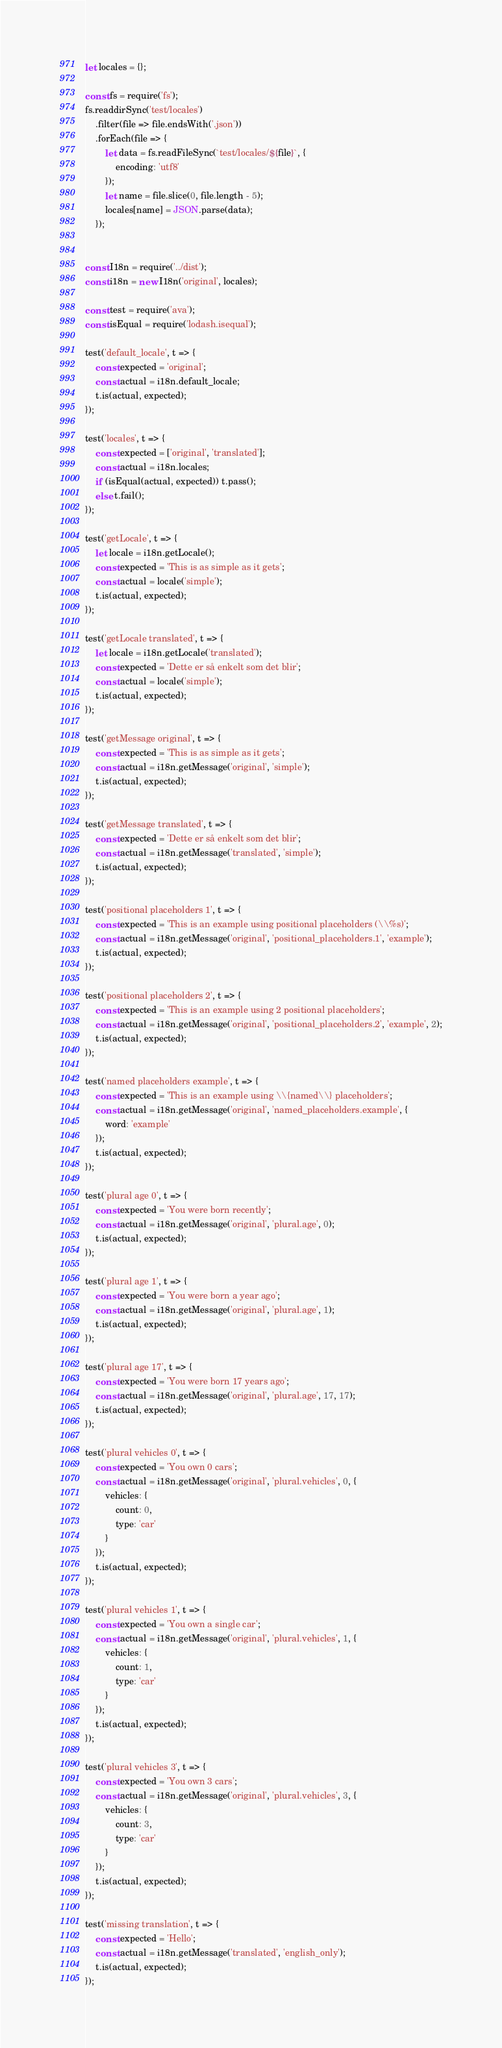Convert code to text. <code><loc_0><loc_0><loc_500><loc_500><_JavaScript_>let locales = {};

const fs = require('fs');
fs.readdirSync('test/locales')
	.filter(file => file.endsWith('.json'))
	.forEach(file => {
		let data = fs.readFileSync(`test/locales/${file}`, {
			encoding: 'utf8'
		});
		let name = file.slice(0, file.length - 5);
		locales[name] = JSON.parse(data);
	});


const I18n = require('../dist');
const i18n = new I18n('original', locales);

const test = require('ava');
const isEqual = require('lodash.isequal');

test('default_locale', t => {
	const expected = 'original';
	const actual = i18n.default_locale;
	t.is(actual, expected);
});

test('locales', t => {
	const expected = ['original', 'translated'];
	const actual = i18n.locales;
	if (isEqual(actual, expected)) t.pass();
	else t.fail();
});

test('getLocale', t => {
	let locale = i18n.getLocale();
	const expected = 'This is as simple as it gets';
	const actual = locale('simple');
	t.is(actual, expected);
});

test('getLocale translated', t => {
	let locale = i18n.getLocale('translated');
	const expected = 'Dette er så enkelt som det blir';
	const actual = locale('simple');
	t.is(actual, expected);
});

test('getMessage original', t => {
	const expected = 'This is as simple as it gets';
	const actual = i18n.getMessage('original', 'simple');
	t.is(actual, expected);
});

test('getMessage translated', t => {
	const expected = 'Dette er så enkelt som det blir';
	const actual = i18n.getMessage('translated', 'simple');
	t.is(actual, expected);
});

test('positional placeholders 1', t => {
	const expected = 'This is an example using positional placeholders (\\%s)';
	const actual = i18n.getMessage('original', 'positional_placeholders.1', 'example');
	t.is(actual, expected);
});

test('positional placeholders 2', t => {
	const expected = 'This is an example using 2 positional placeholders';
	const actual = i18n.getMessage('original', 'positional_placeholders.2', 'example', 2);
	t.is(actual, expected);
});

test('named placeholders example', t => {
	const expected = 'This is an example using \\{named\\} placeholders';
	const actual = i18n.getMessage('original', 'named_placeholders.example', {
		word: 'example'
	});
	t.is(actual, expected);
});

test('plural age 0', t => {
	const expected = 'You were born recently';
	const actual = i18n.getMessage('original', 'plural.age', 0);
	t.is(actual, expected);
});

test('plural age 1', t => {
	const expected = 'You were born a year ago';
	const actual = i18n.getMessage('original', 'plural.age', 1);
	t.is(actual, expected);
});

test('plural age 17', t => {
	const expected = 'You were born 17 years ago';
	const actual = i18n.getMessage('original', 'plural.age', 17, 17);
	t.is(actual, expected);
});

test('plural vehicles 0', t => {
	const expected = 'You own 0 cars';
	const actual = i18n.getMessage('original', 'plural.vehicles', 0, {
		vehicles: {
			count: 0,
			type: 'car'
		}
	});
	t.is(actual, expected);
});

test('plural vehicles 1', t => {
	const expected = 'You own a single car';
	const actual = i18n.getMessage('original', 'plural.vehicles', 1, {
		vehicles: {
			count: 1,
			type: 'car'
		}
	});
	t.is(actual, expected);
});

test('plural vehicles 3', t => {
	const expected = 'You own 3 cars';
	const actual = i18n.getMessage('original', 'plural.vehicles', 3, {
		vehicles: {
			count: 3,
			type: 'car'
		}
	});
	t.is(actual, expected);
});

test('missing translation', t => {
	const expected = 'Hello';
	const actual = i18n.getMessage('translated', 'english_only');
	t.is(actual, expected);
});
</code> 